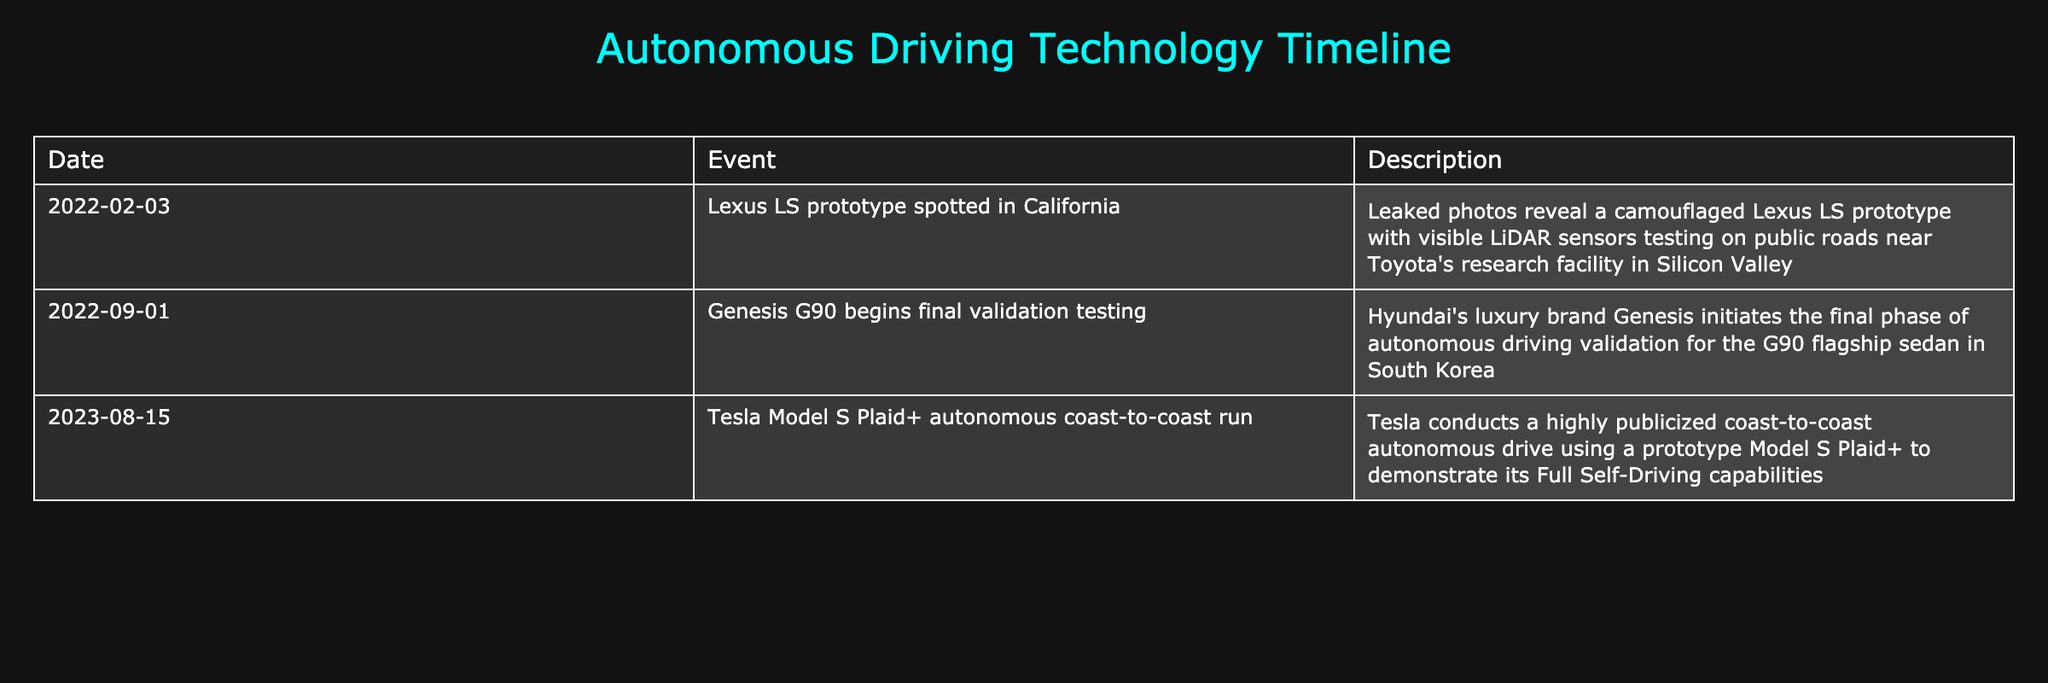What date was the Lexus LS prototype spotted? The table indicates that the Lexus LS prototype was spotted on February 3, 2022.
Answer: February 3, 2022 What event took place on September 1, 2022? According to the table, on September 1, 2022, Genesis G90 began its final validation testing.
Answer: Genesis G90 begins final validation testing Was the Tesla Model S Plaid+ tested for autonomous driving? The table shows that the Tesla Model S Plaid+ was involved in a coast-to-coast autonomous drive, demonstrating its Full Self-Driving capabilities, confirming that it was indeed tested.
Answer: Yes How many events are listed in the table? The table includes three distinct events related to autonomous driving technology testing for luxury sedans.
Answer: 3 Which prototype was tested in California in early 2022? The table specifies that the Lexus LS prototype was tested in California, revealed by leaked photos indicating it had LiDAR sensors.
Answer: Lexus LS What is the chronological order of testing events listed? To determine the order, we can look at the dates; the first event is the Lexus LS on February 3, 2022, followed by Genesis G90 on September 1, 2022, and finally the Tesla Model S Plaid+ on August 15, 2023. Thus, the order is: Lexus LS, Genesis G90, Tesla Model S Plaid+.
Answer: Lexus LS, Genesis G90, Tesla Model S Plaid+ Did the Genesis G90 test occur before the Tesla Model S Plaid+ testing? We see from the table that the Genesis G90 testing happened on September 1, 2022, while the Tesla Model S Plaid+ testing took place on August 15, 2023. Therefore, the Genesis G90 test did occur before the Tesla test.
Answer: Yes What common feature is mentioned for both the Lexus LS and Tesla Model S Plaid+ prototypes? The table mentions that both the Lexus LS and Tesla Model S Plaid+ prototypes included advanced technology; specifically, both had visible LiDAR sensors in the case of the Lexus and were part of demonstrating Full Self-Driving capabilities in the case of Tesla.
Answer: Advanced driving technology How do the locations of the tests differ between the Lexus LS and Genesis G90? The Lexus LS was tested on public roads in California, while the Genesis G90 was tested in South Korea. This indicates that the tests occurred in two different countries.
Answer: California and South Korea 